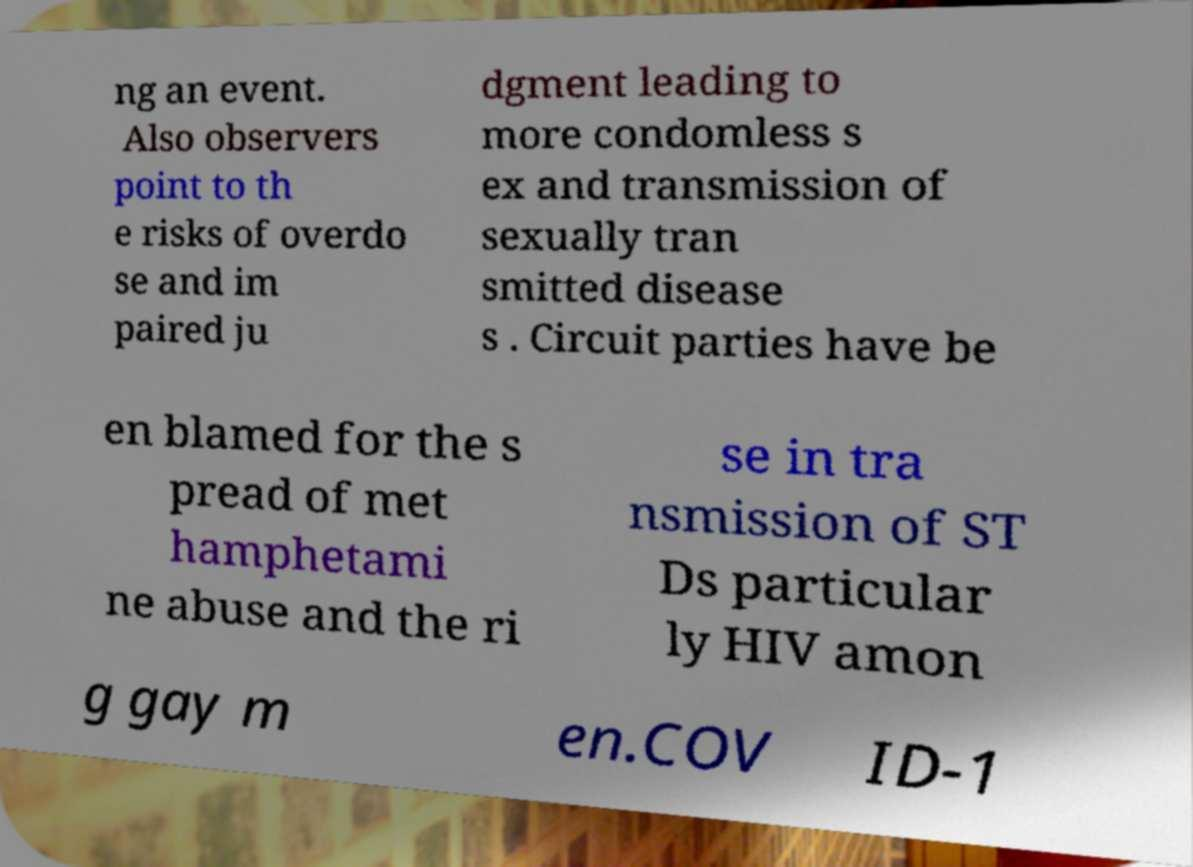There's text embedded in this image that I need extracted. Can you transcribe it verbatim? ng an event. Also observers point to th e risks of overdo se and im paired ju dgment leading to more condomless s ex and transmission of sexually tran smitted disease s . Circuit parties have be en blamed for the s pread of met hamphetami ne abuse and the ri se in tra nsmission of ST Ds particular ly HIV amon g gay m en.COV ID-1 